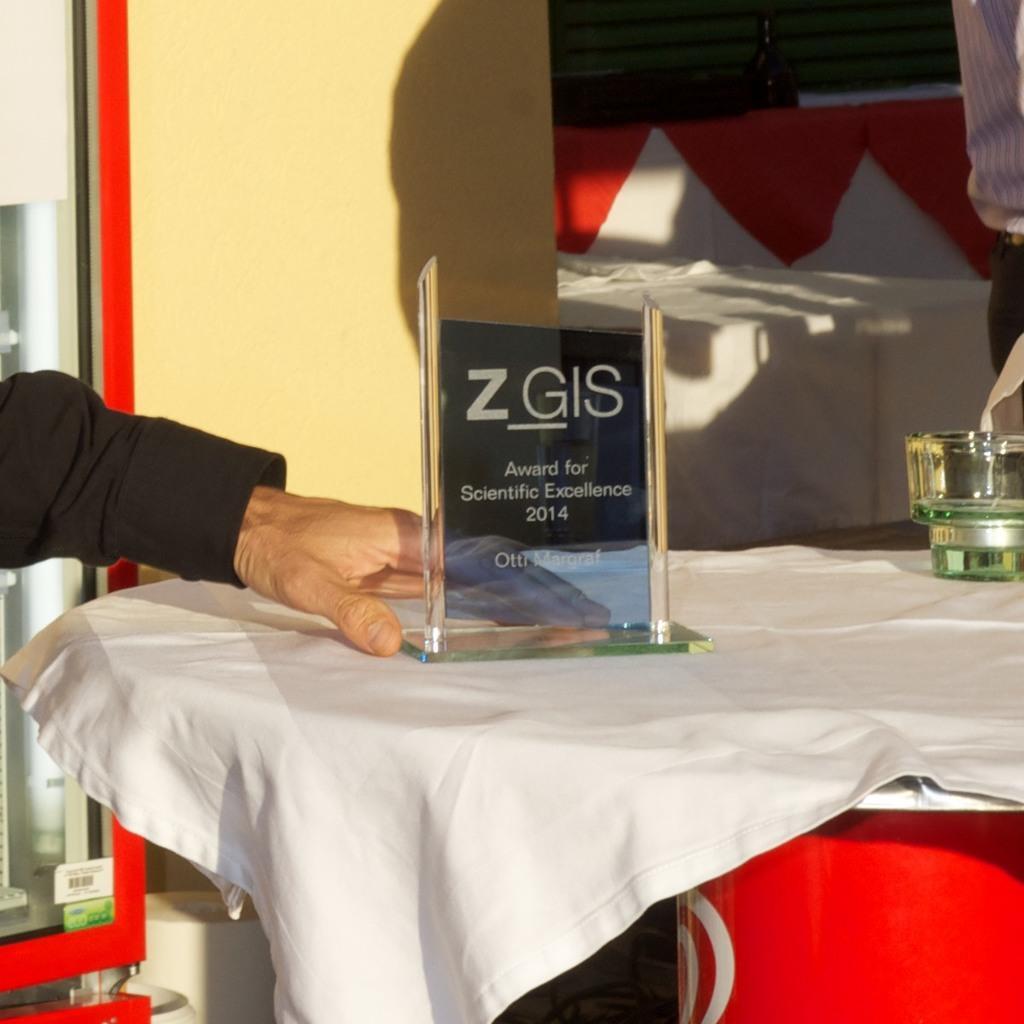Could you give a brief overview of what you see in this image? In this image we can see a person´s hand and a table which is covered with a white color cloth, on the table, we can see a shield and an object, also we can see the curtain, wall and some other objects. 